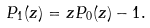<formula> <loc_0><loc_0><loc_500><loc_500>P _ { 1 } ( z ) = z P _ { 0 } ( z ) - 1 .</formula> 